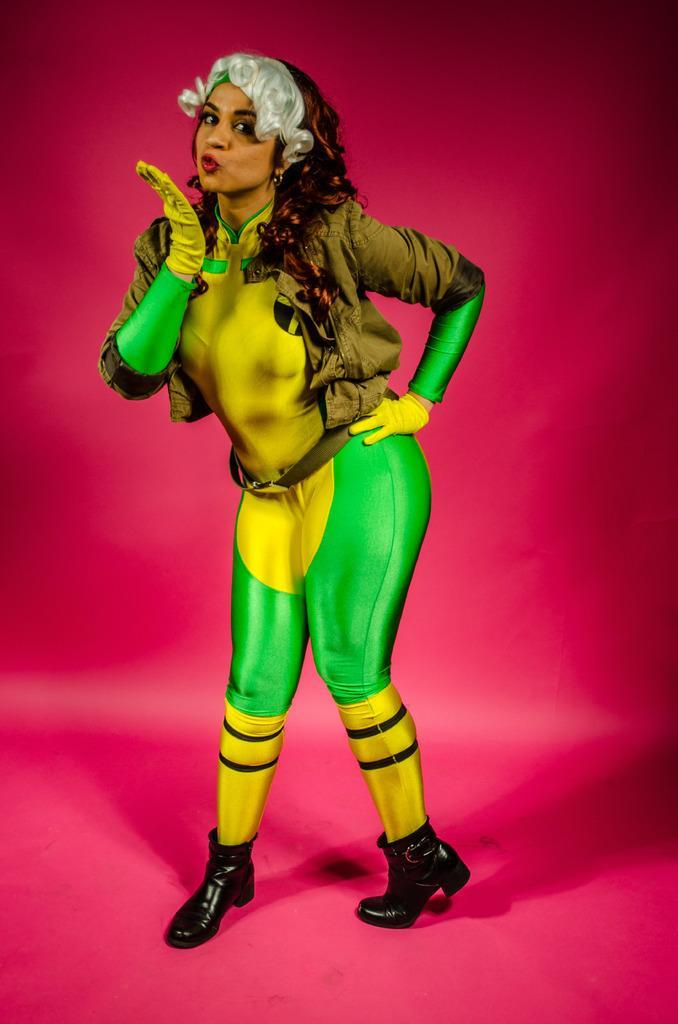Can you describe this image briefly? In this image we can see a lady, and the background is pink in color. 